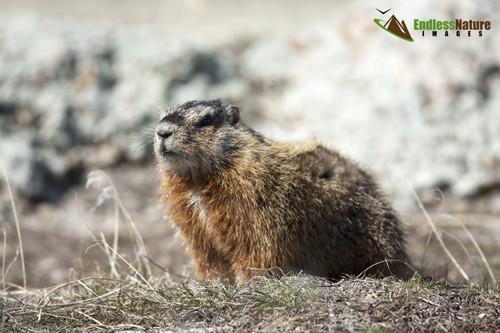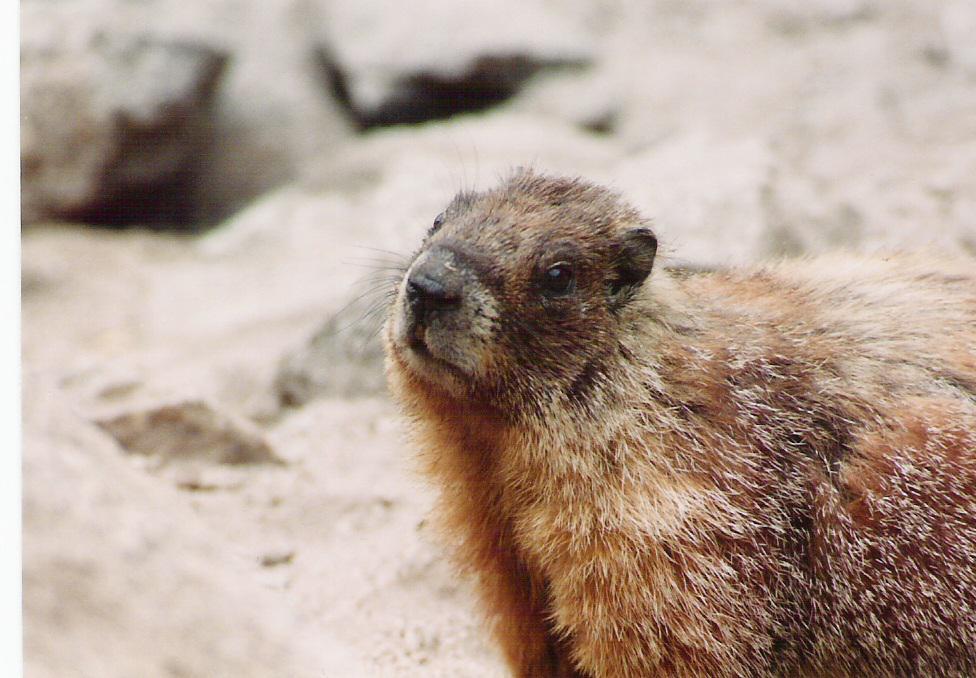The first image is the image on the left, the second image is the image on the right. Given the left and right images, does the statement "At least one rodent-type animal is standing upright." hold true? Answer yes or no. No. 